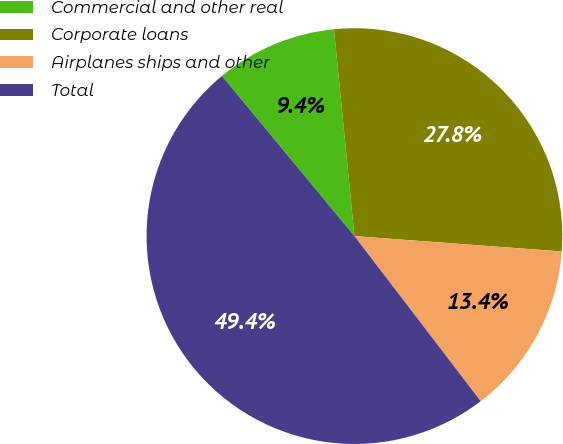Convert chart. <chart><loc_0><loc_0><loc_500><loc_500><pie_chart><fcel>Commercial and other real<fcel>Corporate loans<fcel>Airplanes ships and other<fcel>Total<nl><fcel>9.43%<fcel>27.75%<fcel>13.43%<fcel>49.39%<nl></chart> 